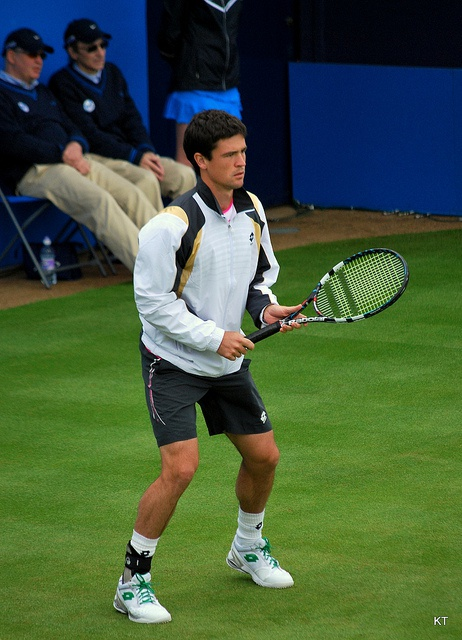Describe the objects in this image and their specific colors. I can see people in darkblue, black, lightgray, olive, and darkgray tones, people in darkblue, black, gray, and tan tones, people in darkblue, black, navy, tan, and gray tones, people in darkblue, black, and blue tones, and tennis racket in darkblue, black, darkgreen, and gray tones in this image. 